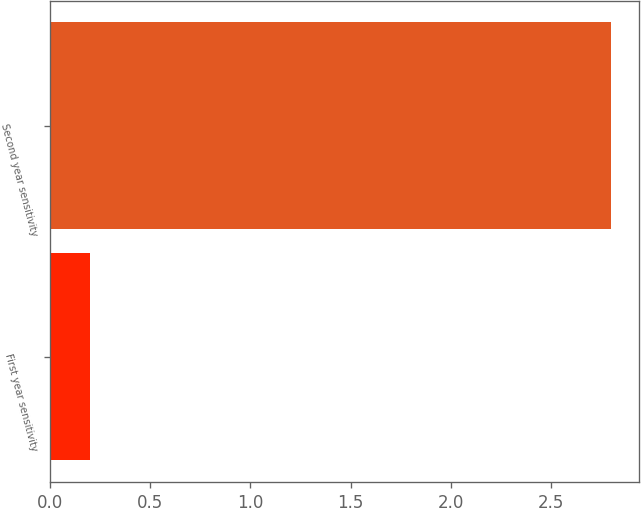Convert chart to OTSL. <chart><loc_0><loc_0><loc_500><loc_500><bar_chart><fcel>First year sensitivity<fcel>Second year sensitivity<nl><fcel>0.2<fcel>2.8<nl></chart> 